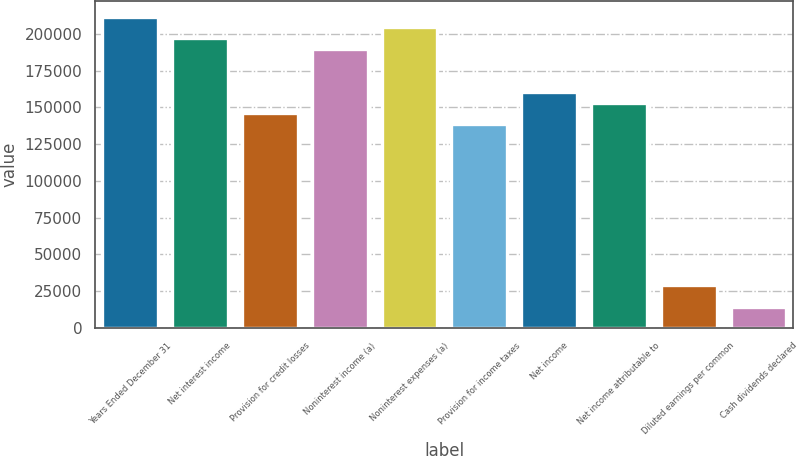Convert chart. <chart><loc_0><loc_0><loc_500><loc_500><bar_chart><fcel>Years Ended December 31<fcel>Net interest income<fcel>Provision for credit losses<fcel>Noninterest income (a)<fcel>Noninterest expenses (a)<fcel>Provision for income taxes<fcel>Net income<fcel>Net income attributable to<fcel>Diluted earnings per common<fcel>Cash dividends declared<nl><fcel>211636<fcel>197040<fcel>145956<fcel>189742<fcel>204338<fcel>138658<fcel>160551<fcel>153253<fcel>29191.4<fcel>14595.9<nl></chart> 